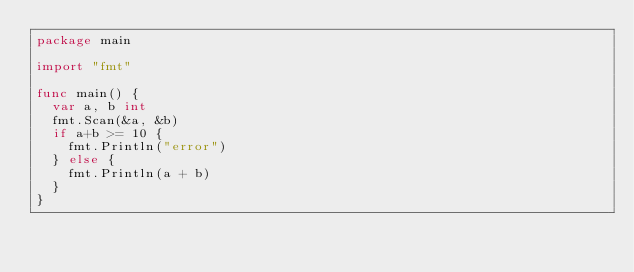Convert code to text. <code><loc_0><loc_0><loc_500><loc_500><_Go_>package main

import "fmt"

func main() {
	var a, b int
	fmt.Scan(&a, &b)
	if a+b >= 10 {
		fmt.Println("error")
	} else {
		fmt.Println(a + b)
	}
}
</code> 